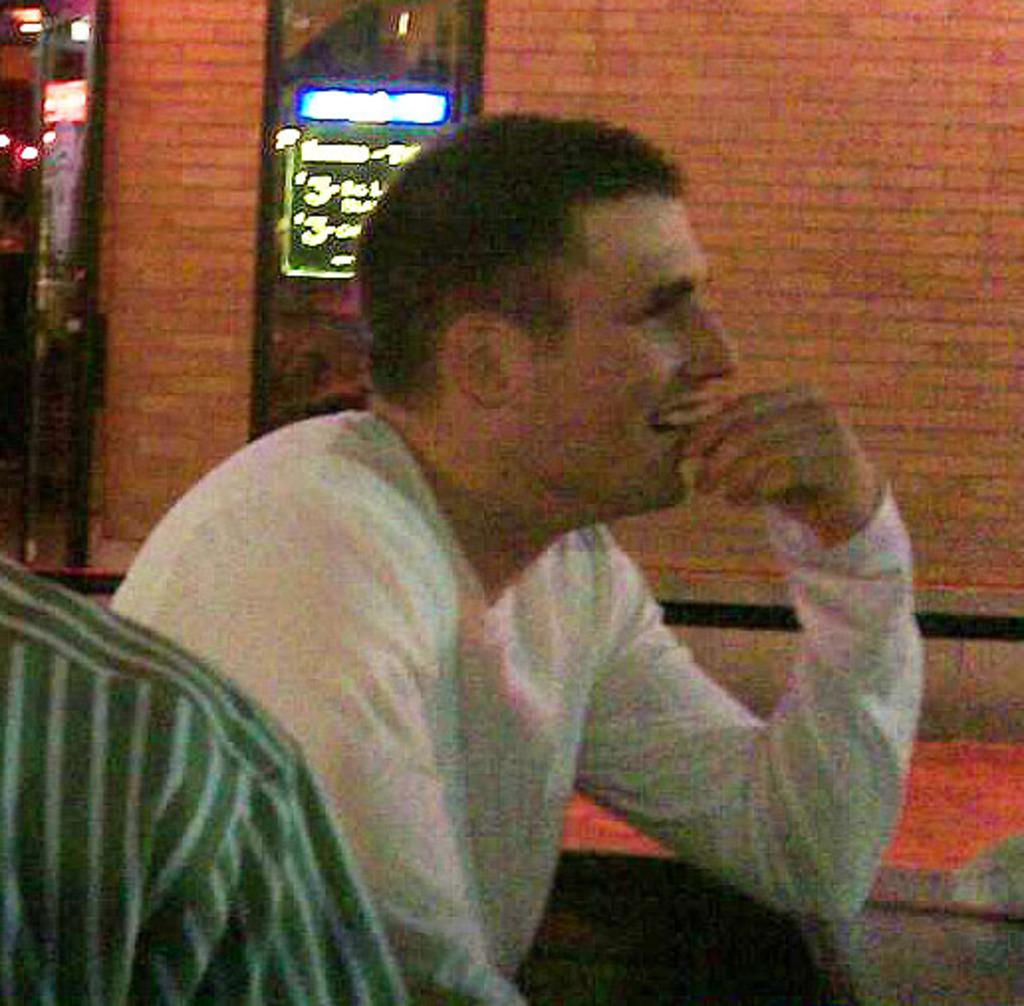What is the man in the image doing? The man is sitting and smiling in the image. Who is with the man in the image? There is another person next to the man. What can be seen in the background of the image? There is a wallboard and a door in the background of the image. What type of laborer is the man in the image? The image does not provide any information about the man's occupation, so it cannot be determined if he is a laborer. What is the nature of the love between the man and the person next to him in the image? The image does not provide any information about the relationship between the man and the person next to him, so it cannot be determined if they share any love. 